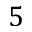Convert formula to latex. <formula><loc_0><loc_0><loc_500><loc_500>5</formula> 